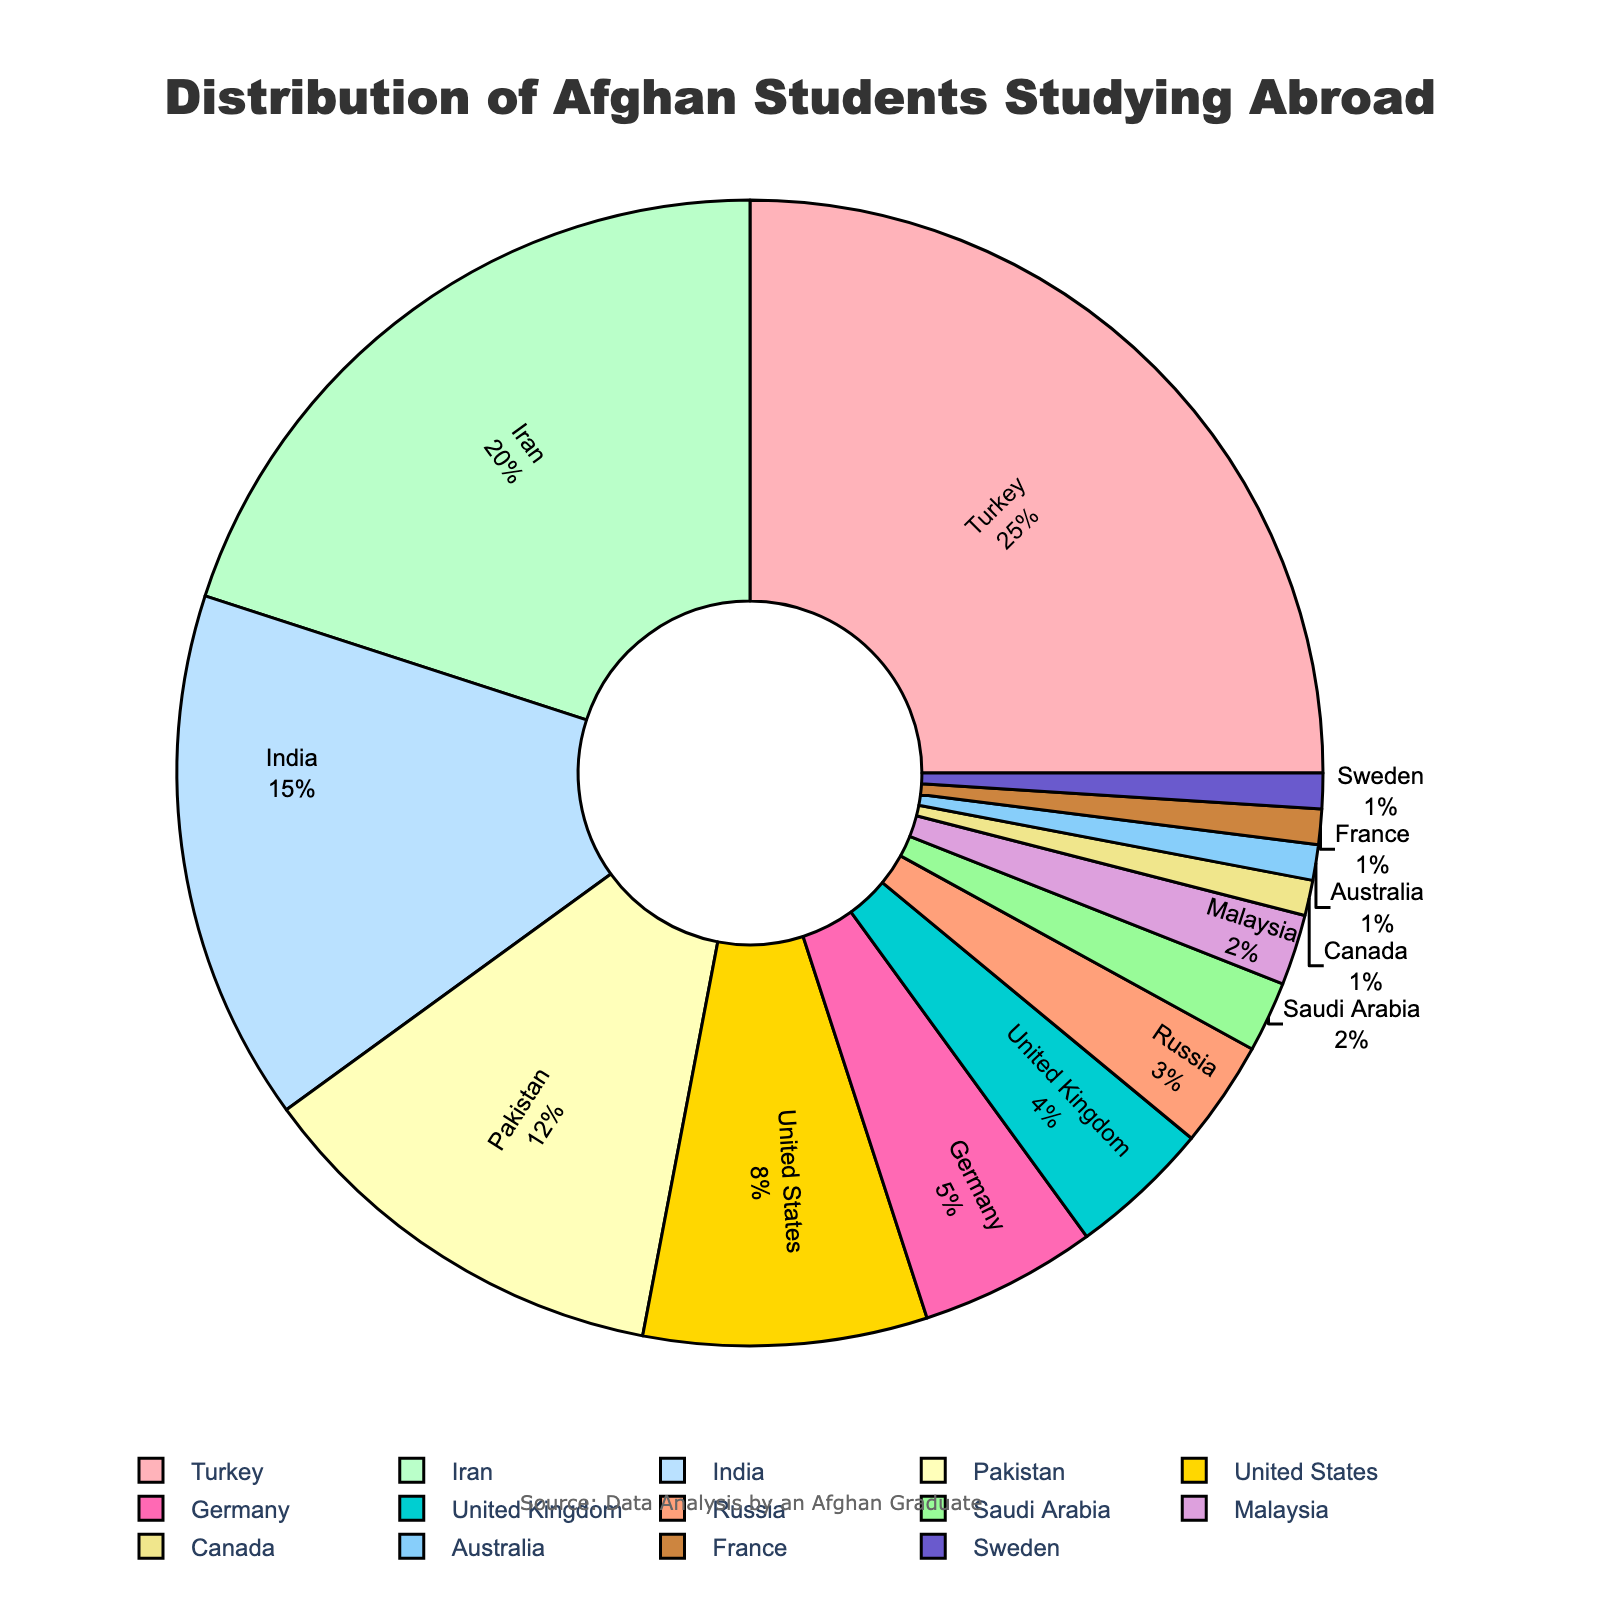Which country has the highest percentage of Afghan students studying abroad? Looking at the pie chart, the segment representing Turkey is largest and contains the highest percentage, which is 25%.
Answer: Turkey Which country has the lowest percentage of Afghan students studying abroad? The smallest segments on the pie chart represent Canada, Australia, France, and Sweden, each with 1%.
Answer: Canada, Australia, France, Sweden What is the combined percentage of Afghan students studying in Turkey, Iran, and India? Adding the percentages of Turkey (25%), Iran (20%), and India (15%) gives 25 + 20 + 15 = 60%.
Answer: 60% Which two countries combined account for the same percentage as Iranian students alone? Iran has 20%. Looking at the chart, the two countries whose percentages sum to 20% are United Kingdom (4%) and Pakistan (12%), and Saudi Arabia (2%) and Russia (3%).
Answer: United Kingdom and Pakistan & Saudi Arabia and Russia How many countries have a percentage of Afghan students greater than or equal to 10%? Evaluating the chart, four countries have a percentage greater than or equal to 10%: Turkey (25%), Iran (20%), India (15%), and Pakistan (12%).
Answer: 4 What is the average percentage of Afghan students in countries with percentages of 5% or more? The countries are Turkey (25%), Iran (20%), India (15%), Pakistan (12%), United States (8%), and Germany (5%). Adding these gives 25 + 20 + 15 + 12 + 8 + 5 = 85%. The average is 85% / 6 = 14.17%.
Answer: 14.17% Which countries have a smaller percentage compared to Saudi Arabia? Saudi Arabia has 2%. The countries with smaller percentages are Canada, Australia, France, and Sweden, each with 1%.
Answer: Canada, Australia, France, Sweden What is the difference in percentage between students studying in Turkey and those in the United States? Turkey has 25%, and the United States has 8%. The difference is 25% - 8% = 17%.
Answer: 17% Which country is represented by the pink segment on the pie chart with a golden outline? Given the custom color palette, the pink color likely corresponds to Turkey, as it is the first color in the list and Turkey has the highest percentage.
Answer: Turkey How does the percentage of students in Germany compare to those in Russia? Germany has 5%, and Russia has 3%. Therefore, Germany has a higher percentage of students than Russia.
Answer: Germany has a higher percentage 